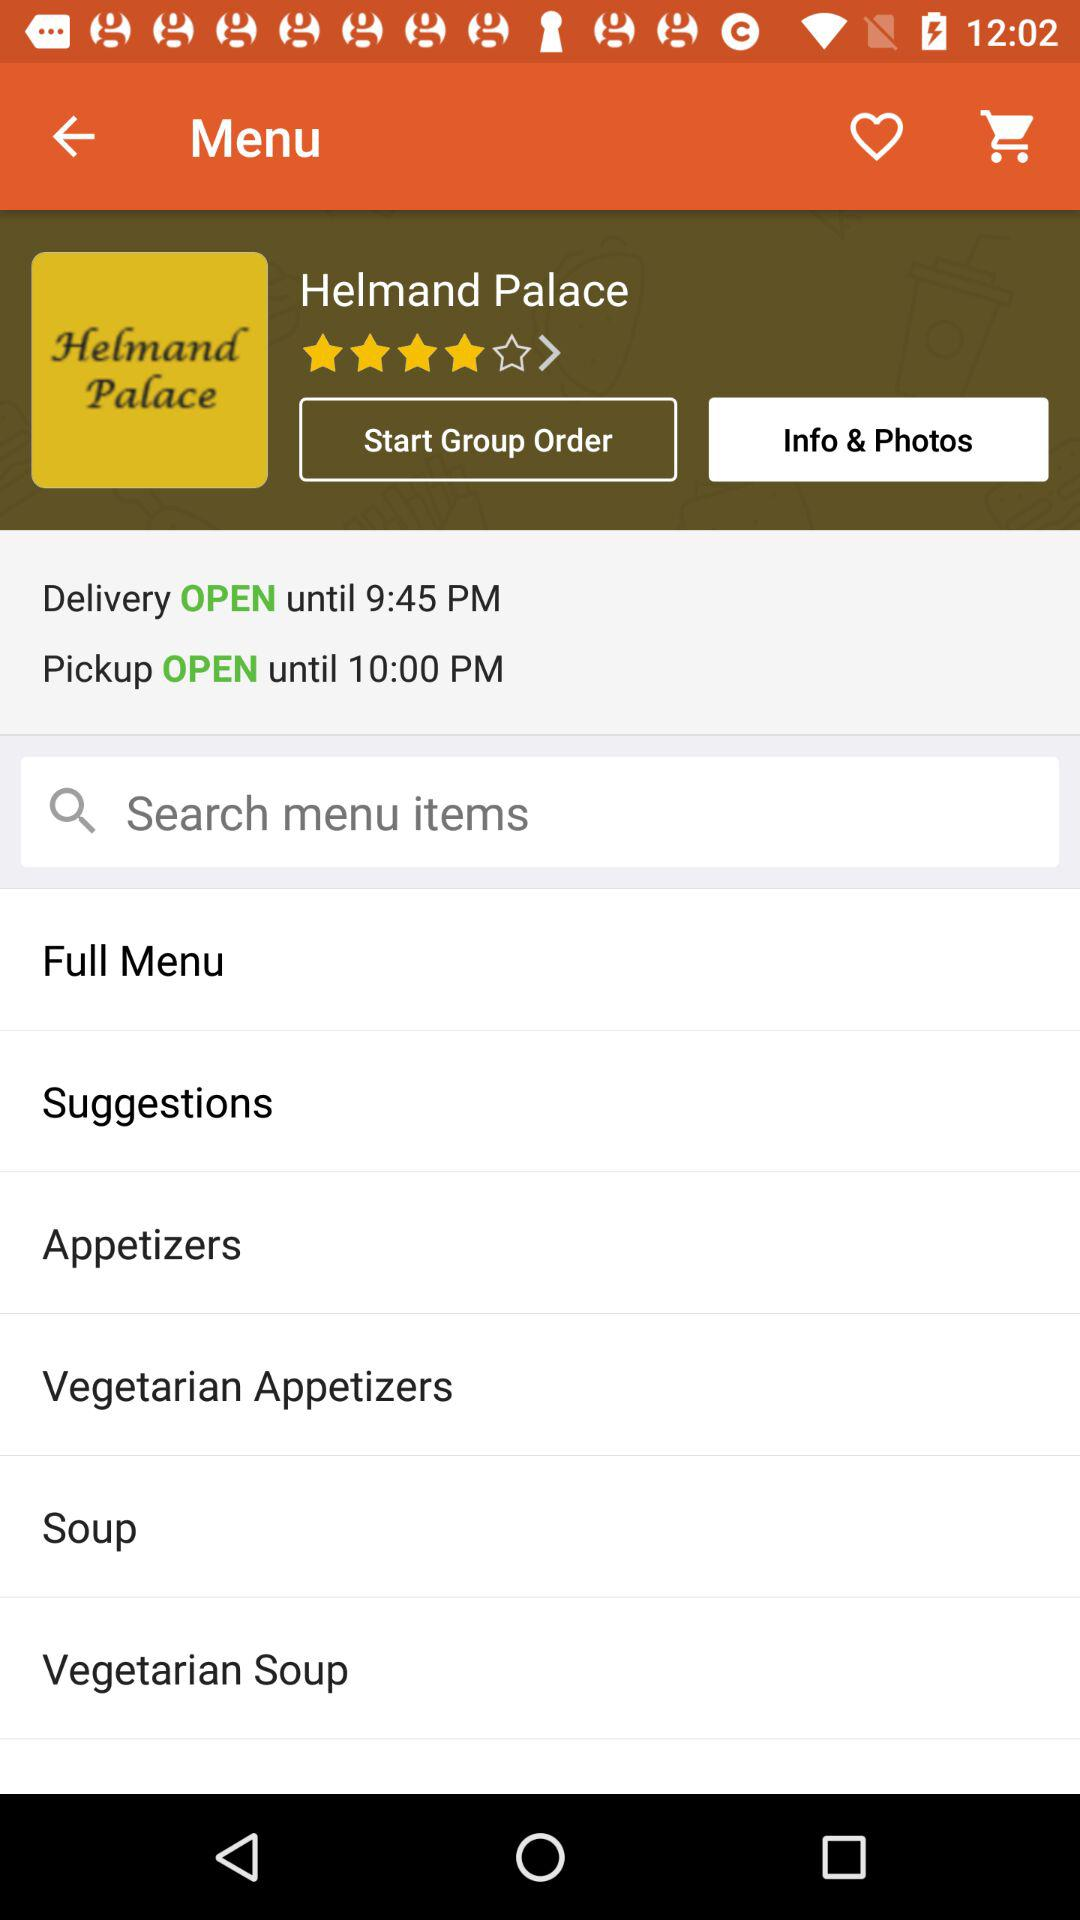What is the selected option? The selected option is "Info & Photos". 